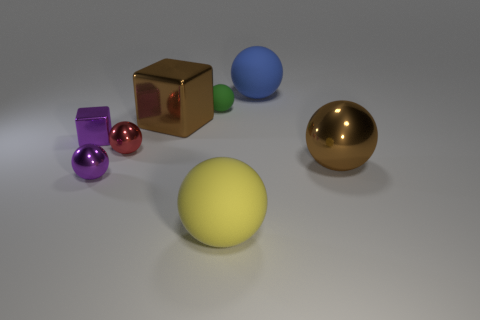The brown block behind the large rubber object in front of the large blue sphere is made of what material?
Keep it short and to the point. Metal. There is a brown thing that is the same material as the big cube; what is its shape?
Give a very brief answer. Sphere. Are there any other things that are the same shape as the green thing?
Make the answer very short. Yes. How many large blue rubber objects are behind the small purple ball?
Your response must be concise. 1. Is there a small gray cube?
Provide a succinct answer. No. There is a metallic ball right of the large matte ball in front of the large brown metal thing right of the blue ball; what is its color?
Offer a terse response. Brown. Is there a brown sphere to the left of the metallic thing on the right side of the blue rubber ball?
Provide a short and direct response. No. Does the rubber ball behind the green sphere have the same color as the tiny rubber object that is behind the brown metal block?
Your response must be concise. No. How many brown metal things have the same size as the blue ball?
Offer a terse response. 2. Does the shiny sphere that is on the right side of the blue matte sphere have the same size as the large yellow object?
Your answer should be very brief. Yes. 